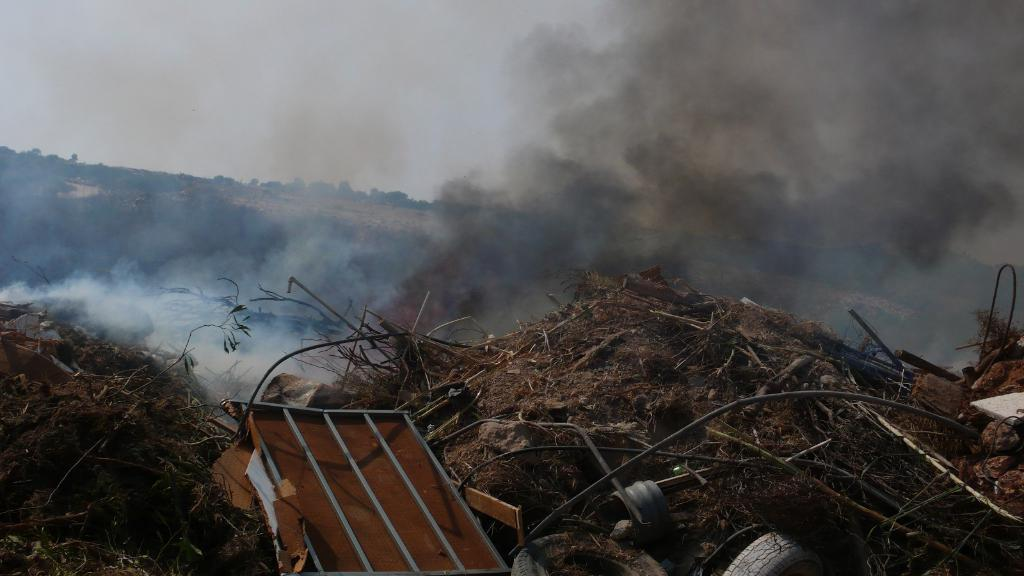What is happening in the dumping yard in the image? There is smoke coming out of the dumping yard in the image. What can be seen behind the dumping yard? There are trees visible behind the dumping yard. What type of materials are present in the dumping yard? There are scrap materials present in the dumping yard. Where is the best spot to sort the scrap materials in the image? There is no indication in the image of a specific spot for sorting scrap materials, as the focus is on the smoke coming out of the dumping yard. 